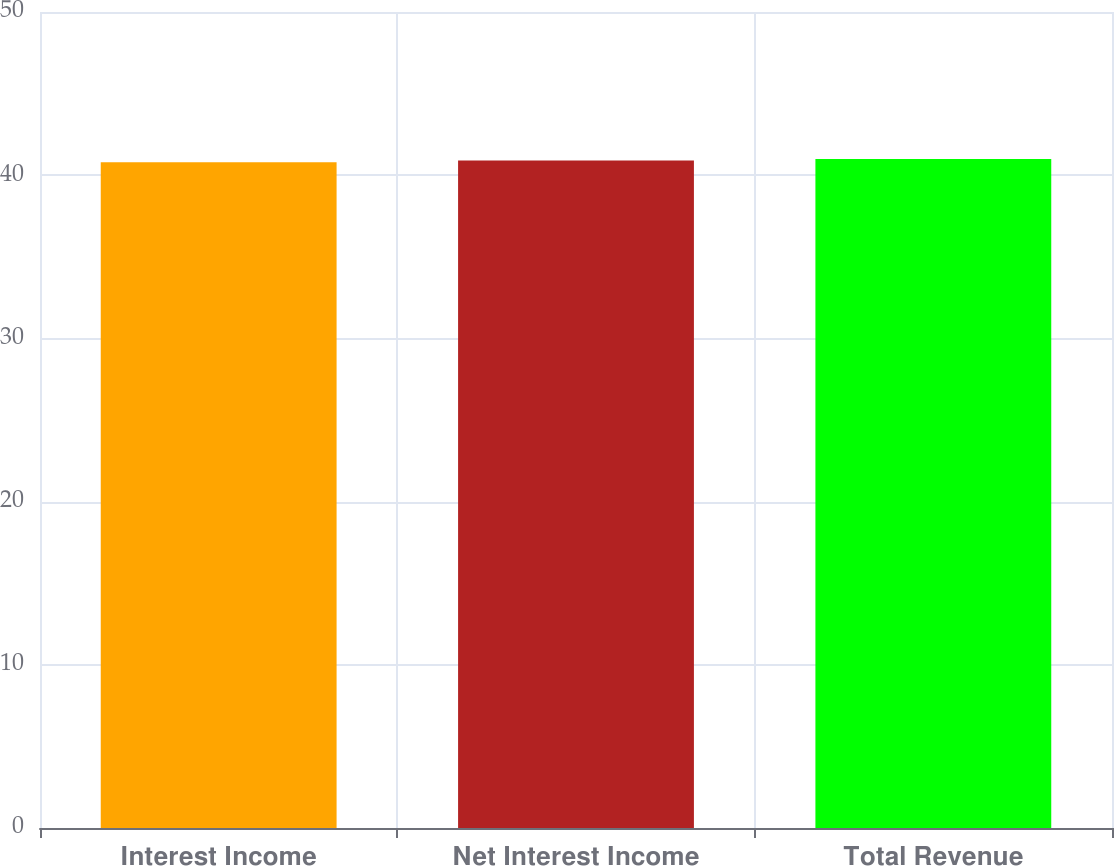Convert chart to OTSL. <chart><loc_0><loc_0><loc_500><loc_500><bar_chart><fcel>Interest Income<fcel>Net Interest Income<fcel>Total Revenue<nl><fcel>40.8<fcel>40.9<fcel>41<nl></chart> 